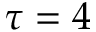<formula> <loc_0><loc_0><loc_500><loc_500>\tau = 4</formula> 